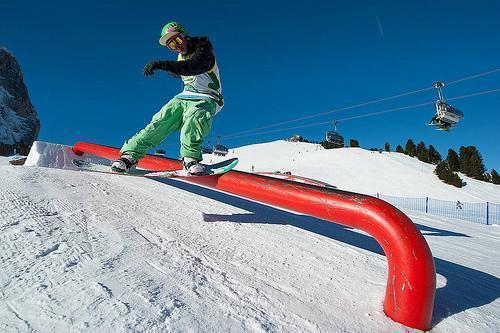How many people are on the red pole?
Give a very brief answer. 1. 